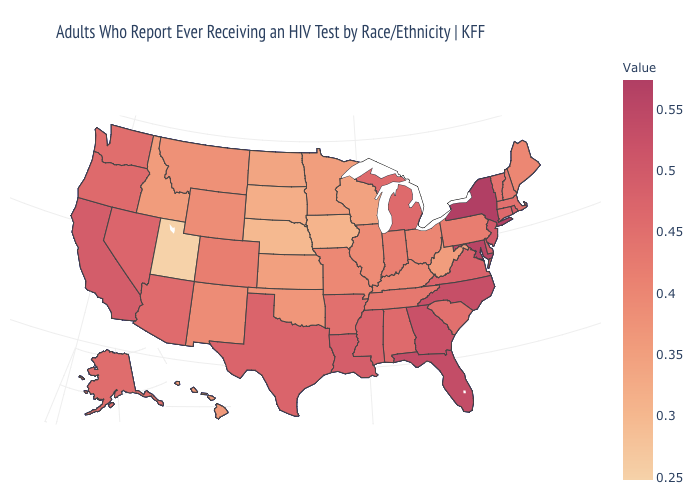Is the legend a continuous bar?
Concise answer only. Yes. Among the states that border South Dakota , does Nebraska have the lowest value?
Write a very short answer. Yes. Which states have the highest value in the USA?
Write a very short answer. New York. Is the legend a continuous bar?
Concise answer only. Yes. Among the states that border Missouri , does Kentucky have the highest value?
Short answer required. No. Does Hawaii have a higher value than Kentucky?
Short answer required. No. 